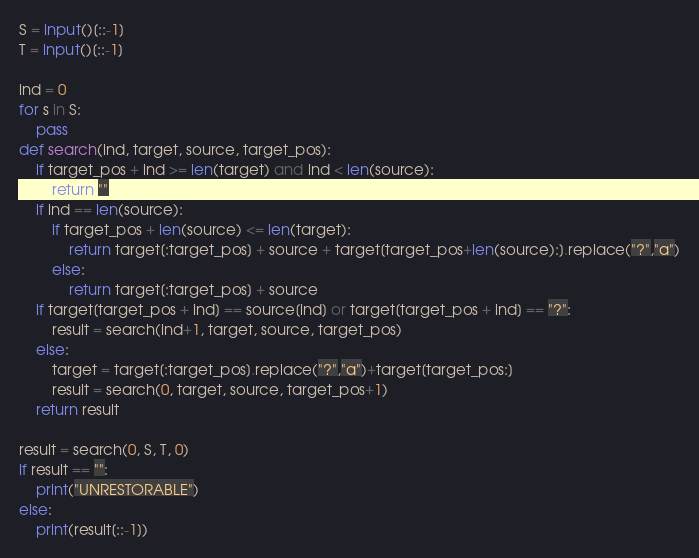<code> <loc_0><loc_0><loc_500><loc_500><_Python_>S = input()[::-1]
T = input()[::-1]

ind = 0
for s in S:
    pass
def search(ind, target, source, target_pos):
    if target_pos + ind >= len(target) and ind < len(source):
        return ""
    if ind == len(source):
        if target_pos + len(source) <= len(target):
            return target[:target_pos] + source + target[target_pos+len(source):].replace("?","a")
        else:
            return target[:target_pos] + source
    if target[target_pos + ind] == source[ind] or target[target_pos + ind] == "?":
        result = search(ind+1, target, source, target_pos)
    else:
        target = target[:target_pos].replace("?","a")+target[target_pos:]
        result = search(0, target, source, target_pos+1)
    return result

result = search(0, S, T, 0)
if result == "":
    print("UNRESTORABLE")
else:
    print(result[::-1])</code> 